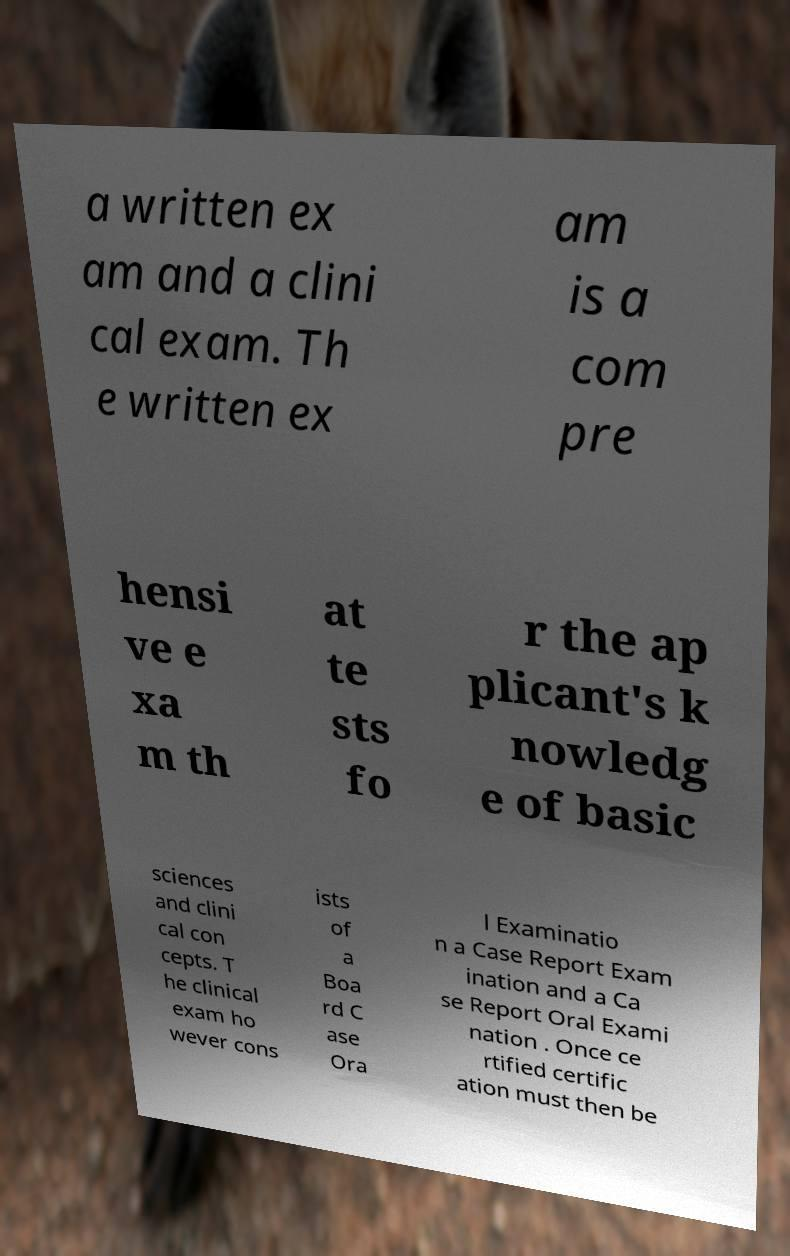There's text embedded in this image that I need extracted. Can you transcribe it verbatim? a written ex am and a clini cal exam. Th e written ex am is a com pre hensi ve e xa m th at te sts fo r the ap plicant's k nowledg e of basic sciences and clini cal con cepts. T he clinical exam ho wever cons ists of a Boa rd C ase Ora l Examinatio n a Case Report Exam ination and a Ca se Report Oral Exami nation . Once ce rtified certific ation must then be 